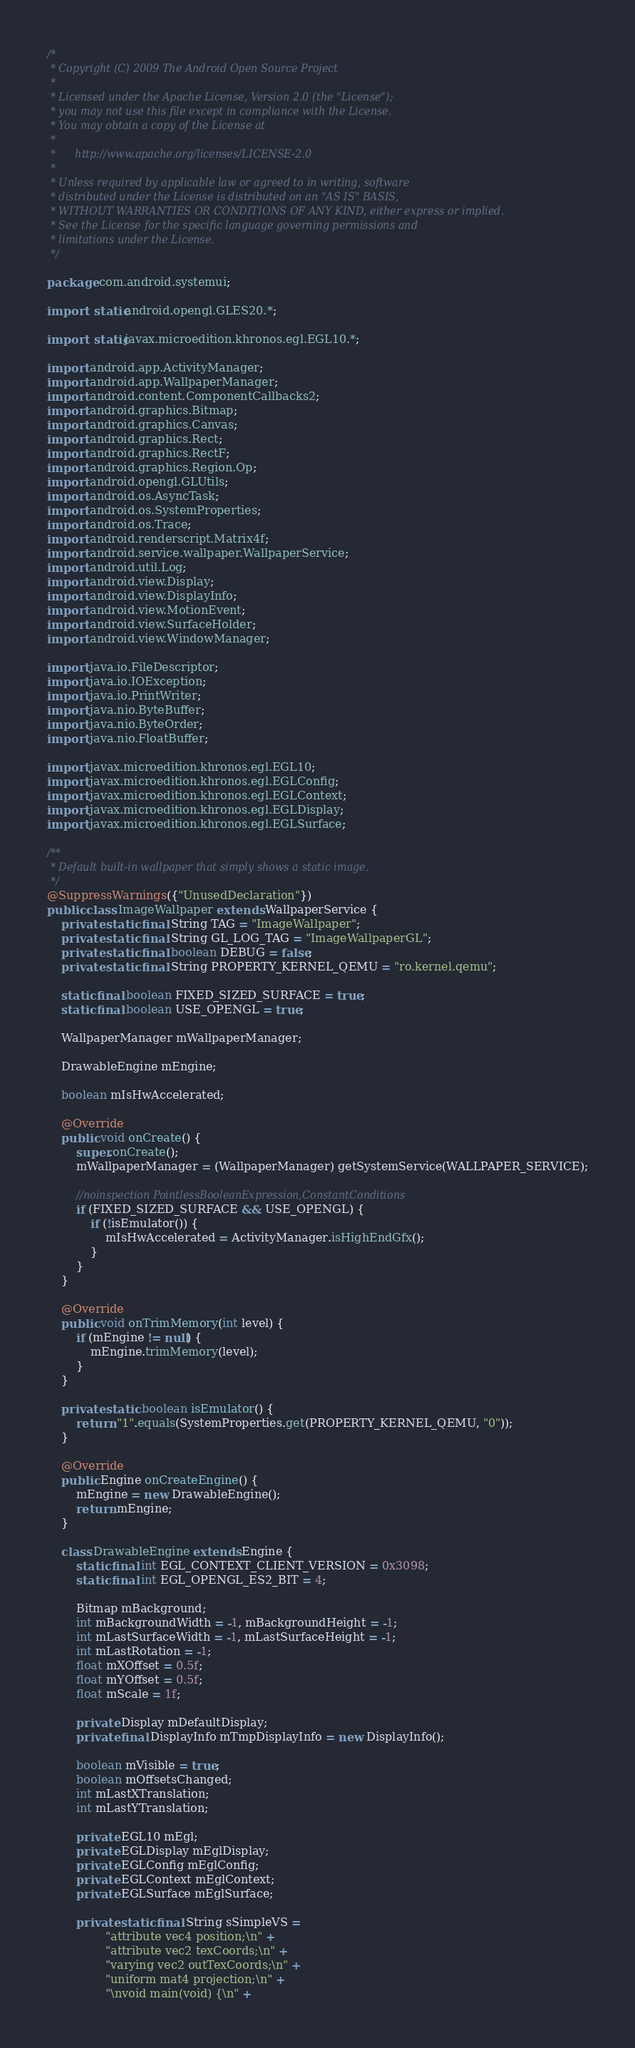Convert code to text. <code><loc_0><loc_0><loc_500><loc_500><_Java_>/*
 * Copyright (C) 2009 The Android Open Source Project
 *
 * Licensed under the Apache License, Version 2.0 (the "License");
 * you may not use this file except in compliance with the License.
 * You may obtain a copy of the License at
 *
 *      http://www.apache.org/licenses/LICENSE-2.0
 *
 * Unless required by applicable law or agreed to in writing, software
 * distributed under the License is distributed on an "AS IS" BASIS,
 * WITHOUT WARRANTIES OR CONDITIONS OF ANY KIND, either express or implied.
 * See the License for the specific language governing permissions and
 * limitations under the License.
 */

package com.android.systemui;

import static android.opengl.GLES20.*;

import static javax.microedition.khronos.egl.EGL10.*;

import android.app.ActivityManager;
import android.app.WallpaperManager;
import android.content.ComponentCallbacks2;
import android.graphics.Bitmap;
import android.graphics.Canvas;
import android.graphics.Rect;
import android.graphics.RectF;
import android.graphics.Region.Op;
import android.opengl.GLUtils;
import android.os.AsyncTask;
import android.os.SystemProperties;
import android.os.Trace;
import android.renderscript.Matrix4f;
import android.service.wallpaper.WallpaperService;
import android.util.Log;
import android.view.Display;
import android.view.DisplayInfo;
import android.view.MotionEvent;
import android.view.SurfaceHolder;
import android.view.WindowManager;

import java.io.FileDescriptor;
import java.io.IOException;
import java.io.PrintWriter;
import java.nio.ByteBuffer;
import java.nio.ByteOrder;
import java.nio.FloatBuffer;

import javax.microedition.khronos.egl.EGL10;
import javax.microedition.khronos.egl.EGLConfig;
import javax.microedition.khronos.egl.EGLContext;
import javax.microedition.khronos.egl.EGLDisplay;
import javax.microedition.khronos.egl.EGLSurface;

/**
 * Default built-in wallpaper that simply shows a static image.
 */
@SuppressWarnings({"UnusedDeclaration"})
public class ImageWallpaper extends WallpaperService {
    private static final String TAG = "ImageWallpaper";
    private static final String GL_LOG_TAG = "ImageWallpaperGL";
    private static final boolean DEBUG = false;
    private static final String PROPERTY_KERNEL_QEMU = "ro.kernel.qemu";

    static final boolean FIXED_SIZED_SURFACE = true;
    static final boolean USE_OPENGL = true;

    WallpaperManager mWallpaperManager;

    DrawableEngine mEngine;

    boolean mIsHwAccelerated;

    @Override
    public void onCreate() {
        super.onCreate();
        mWallpaperManager = (WallpaperManager) getSystemService(WALLPAPER_SERVICE);

        //noinspection PointlessBooleanExpression,ConstantConditions
        if (FIXED_SIZED_SURFACE && USE_OPENGL) {
            if (!isEmulator()) {
                mIsHwAccelerated = ActivityManager.isHighEndGfx();
            }
        }
    }

    @Override
    public void onTrimMemory(int level) {
        if (mEngine != null) {
            mEngine.trimMemory(level);
        }
    }

    private static boolean isEmulator() {
        return "1".equals(SystemProperties.get(PROPERTY_KERNEL_QEMU, "0"));
    }

    @Override
    public Engine onCreateEngine() {
        mEngine = new DrawableEngine();
        return mEngine;
    }

    class DrawableEngine extends Engine {
        static final int EGL_CONTEXT_CLIENT_VERSION = 0x3098;
        static final int EGL_OPENGL_ES2_BIT = 4;

        Bitmap mBackground;
        int mBackgroundWidth = -1, mBackgroundHeight = -1;
        int mLastSurfaceWidth = -1, mLastSurfaceHeight = -1;
        int mLastRotation = -1;
        float mXOffset = 0.5f;
        float mYOffset = 0.5f;
        float mScale = 1f;

        private Display mDefaultDisplay;
        private final DisplayInfo mTmpDisplayInfo = new DisplayInfo();

        boolean mVisible = true;
        boolean mOffsetsChanged;
        int mLastXTranslation;
        int mLastYTranslation;

        private EGL10 mEgl;
        private EGLDisplay mEglDisplay;
        private EGLConfig mEglConfig;
        private EGLContext mEglContext;
        private EGLSurface mEglSurface;

        private static final String sSimpleVS =
                "attribute vec4 position;\n" +
                "attribute vec2 texCoords;\n" +
                "varying vec2 outTexCoords;\n" +
                "uniform mat4 projection;\n" +
                "\nvoid main(void) {\n" +</code> 